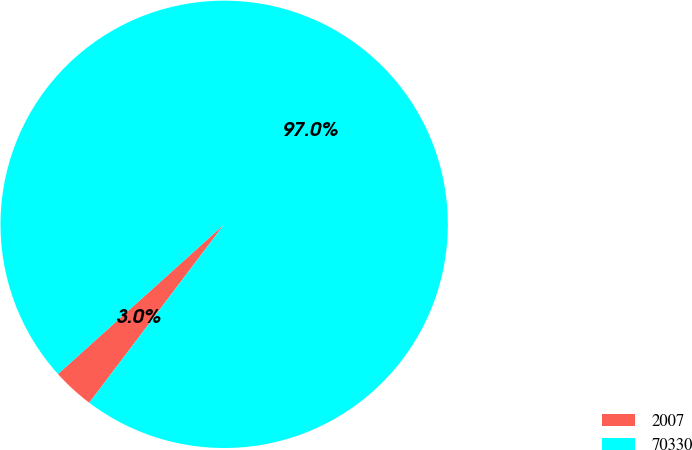Convert chart. <chart><loc_0><loc_0><loc_500><loc_500><pie_chart><fcel>2007<fcel>70330<nl><fcel>3.03%<fcel>96.97%<nl></chart> 